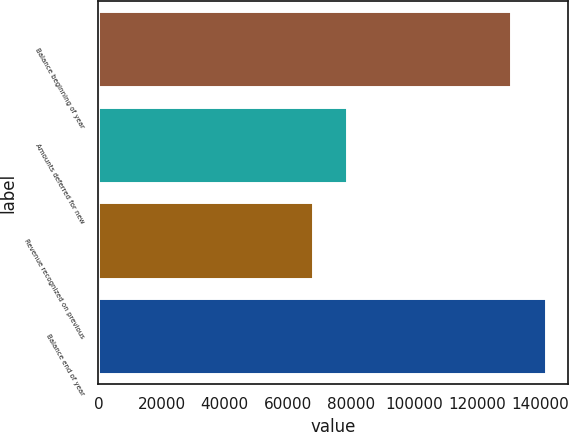<chart> <loc_0><loc_0><loc_500><loc_500><bar_chart><fcel>Balance beginning of year<fcel>Amounts deferred for new<fcel>Revenue recognized on previous<fcel>Balance end of year<nl><fcel>130762<fcel>78900<fcel>67978<fcel>141684<nl></chart> 